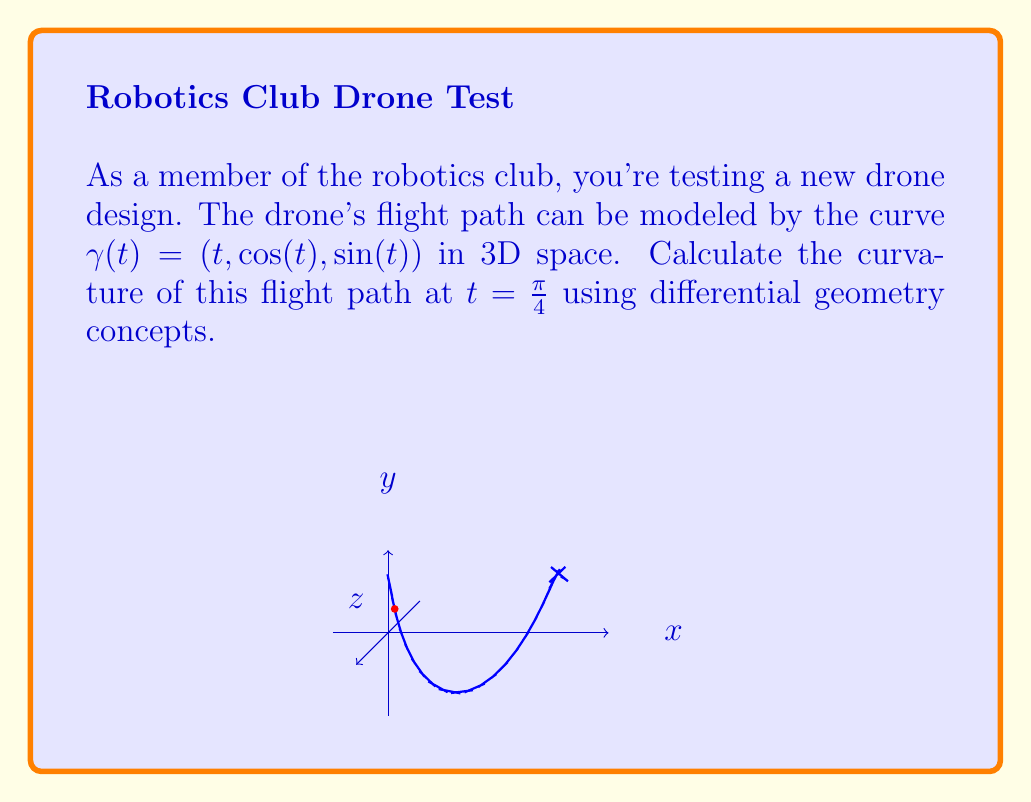Can you answer this question? To calculate the curvature of the flight path, we'll follow these steps:

1) The curvature $\kappa$ is given by the formula:

   $$\kappa = \frac{|\gamma'(t) \times \gamma''(t)|}{|\gamma'(t)|^3}$$

2) First, let's calculate $\gamma'(t)$:
   $$\gamma'(t) = (1, -\sin(t), \cos(t))$$

3) Now, let's calculate $\gamma''(t)$:
   $$\gamma''(t) = (0, -\cos(t), -\sin(t))$$

4) At $t = \frac{\pi}{4}$:
   $$\gamma'(\frac{\pi}{4}) = (1, -\frac{\sqrt{2}}{2}, \frac{\sqrt{2}}{2})$$
   $$\gamma''(\frac{\pi}{4}) = (0, -\frac{\sqrt{2}}{2}, -\frac{\sqrt{2}}{2})$$

5) Calculate the cross product $\gamma'(\frac{\pi}{4}) \times \gamma''(\frac{\pi}{4})$:
   $$\gamma'(\frac{\pi}{4}) \times \gamma''(\frac{\pi}{4}) = (\frac{1}{2}, \frac{\sqrt{2}}{2}, -\frac{\sqrt{2}}{2})$$

6) Calculate $|\gamma'(\frac{\pi}{4}) \times \gamma''(\frac{\pi}{4})|$:
   $$|\gamma'(\frac{\pi}{4}) \times \gamma''(\frac{\pi}{4})| = \sqrt{(\frac{1}{2})^2 + (\frac{\sqrt{2}}{2})^2 + (-\frac{\sqrt{2}}{2})^2} = 1$$

7) Calculate $|\gamma'(\frac{\pi}{4})|$:
   $$|\gamma'(\frac{\pi}{4})| = \sqrt{1^2 + (-\frac{\sqrt{2}}{2})^2 + (\frac{\sqrt{2}}{2})^2} = \sqrt{2}$$

8) Now we can plug these values into the curvature formula:
   $$\kappa = \frac{|\gamma'(\frac{\pi}{4}) \times \gamma''(\frac{\pi}{4})|}{|\gamma'(\frac{\pi}{4})|^3} = \frac{1}{(\sqrt{2})^3} = \frac{1}{2\sqrt{2}}$$

Thus, the curvature of the drone's flight path at $t = \frac{\pi}{4}$ is $\frac{1}{2\sqrt{2}}$.
Answer: $\frac{1}{2\sqrt{2}}$ 